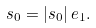Convert formula to latex. <formula><loc_0><loc_0><loc_500><loc_500>s _ { 0 } = | s _ { 0 } | \, e _ { 1 } .</formula> 